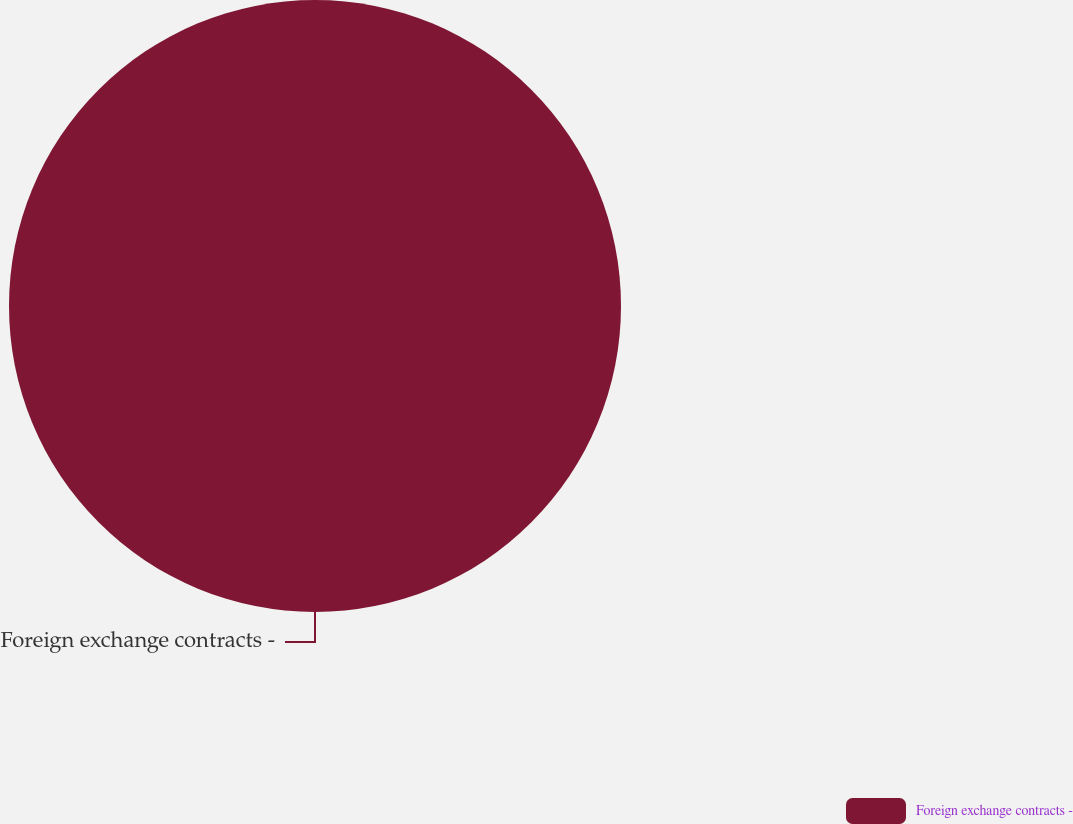Convert chart to OTSL. <chart><loc_0><loc_0><loc_500><loc_500><pie_chart><fcel>Foreign exchange contracts -<nl><fcel>100.0%<nl></chart> 